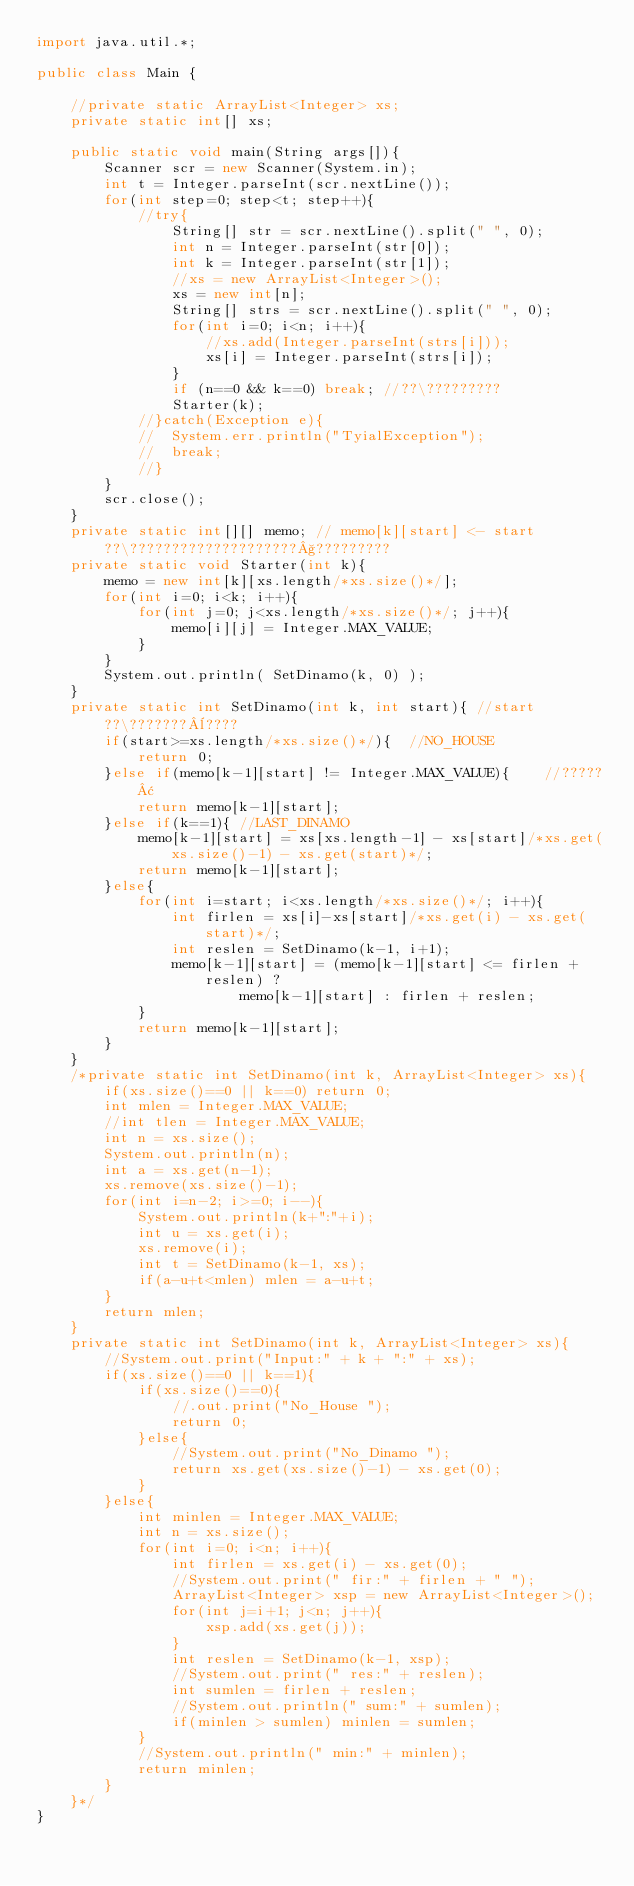Convert code to text. <code><loc_0><loc_0><loc_500><loc_500><_Java_>import java.util.*;

public class Main {
	
	//private static ArrayList<Integer> xs;
	private static int[] xs;
	
	public static void main(String args[]){
		Scanner scr = new Scanner(System.in);
		int t = Integer.parseInt(scr.nextLine());
		for(int step=0; step<t; step++){
		    //try{
				String[] str = scr.nextLine().split(" ", 0);
				int n = Integer.parseInt(str[0]);
				int k = Integer.parseInt(str[1]);
				//xs = new ArrayList<Integer>();
				xs = new int[n];
				String[] strs = scr.nextLine().split(" ", 0);
				for(int i=0; i<n; i++){
					//xs.add(Integer.parseInt(strs[i]));
					xs[i] = Integer.parseInt(strs[i]);
				}
				if (n==0 && k==0) break; //??\?????????
				Starter(k);
			//}catch(Exception e){
			//	System.err.println("TyialException");
			//	break;
			//}
        }
		scr.close();
	}
	private static int[][] memo; // memo[k][start] <- start??\????????????????????§?????????
	private static void Starter(int k){
		memo = new int[k][xs.length/*xs.size()*/];
		for(int i=0; i<k; i++){
			for(int j=0; j<xs.length/*xs.size()*/; j++){
				memo[i][j] = Integer.MAX_VALUE;
			}
		}
		System.out.println( SetDinamo(k, 0) );
	}
	private static int SetDinamo(int k, int start){ //start??\???????¨????
		if(start>=xs.length/*xs.size()*/){	//NO_HOUSE
			return 0;
		}else if(memo[k-1][start] != Integer.MAX_VALUE){	//?????¢
			return memo[k-1][start];
		}else if(k==1){	//LAST_DINAMO
			memo[k-1][start] = xs[xs.length-1] - xs[start]/*xs.get(xs.size()-1) - xs.get(start)*/;
			return memo[k-1][start];
		}else{
			for(int i=start; i<xs.length/*xs.size()*/; i++){
				int firlen = xs[i]-xs[start]/*xs.get(i) - xs.get(start)*/;
				int reslen = SetDinamo(k-1, i+1);
				memo[k-1][start] = (memo[k-1][start] <= firlen + reslen) ?
						memo[k-1][start] : firlen + reslen;
			}
			return memo[k-1][start];
		}
	}	
	/*private static int SetDinamo(int k, ArrayList<Integer> xs){
		if(xs.size()==0 || k==0) return 0;
		int mlen = Integer.MAX_VALUE;
		//int tlen = Integer.MAX_VALUE;
		int n = xs.size();
		System.out.println(n);
		int a = xs.get(n-1);
		xs.remove(xs.size()-1);
		for(int i=n-2; i>=0; i--){
			System.out.println(k+":"+i);
			int u = xs.get(i);
			xs.remove(i);
			int t = SetDinamo(k-1, xs);
			if(a-u+t<mlen) mlen = a-u+t;
		}
	    return mlen;
	}
	private static int SetDinamo(int k, ArrayList<Integer> xs){
		//System.out.print("Input:" + k + ":" + xs);
		if(xs.size()==0 || k==1){
			if(xs.size()==0){
				//.out.print("No_House ");
				return 0;
			}else{
				//System.out.print("No_Dinamo ");
				return xs.get(xs.size()-1) - xs.get(0);
			}
		}else{
			int minlen = Integer.MAX_VALUE;
			int n = xs.size();
			for(int i=0; i<n; i++){
				int firlen = xs.get(i) - xs.get(0);
				//System.out.print(" fir:" + firlen + " ");
				ArrayList<Integer> xsp = new ArrayList<Integer>();
				for(int j=i+1; j<n; j++){
					xsp.add(xs.get(j));
				}
				int reslen = SetDinamo(k-1, xsp);
				//System.out.print(" res:" + reslen);
				int sumlen = firlen + reslen;
				//System.out.println(" sum:" + sumlen);
				if(minlen > sumlen) minlen = sumlen;
			}
			//System.out.println(" min:" + minlen);
			return minlen;
		}
	}*/
}</code> 